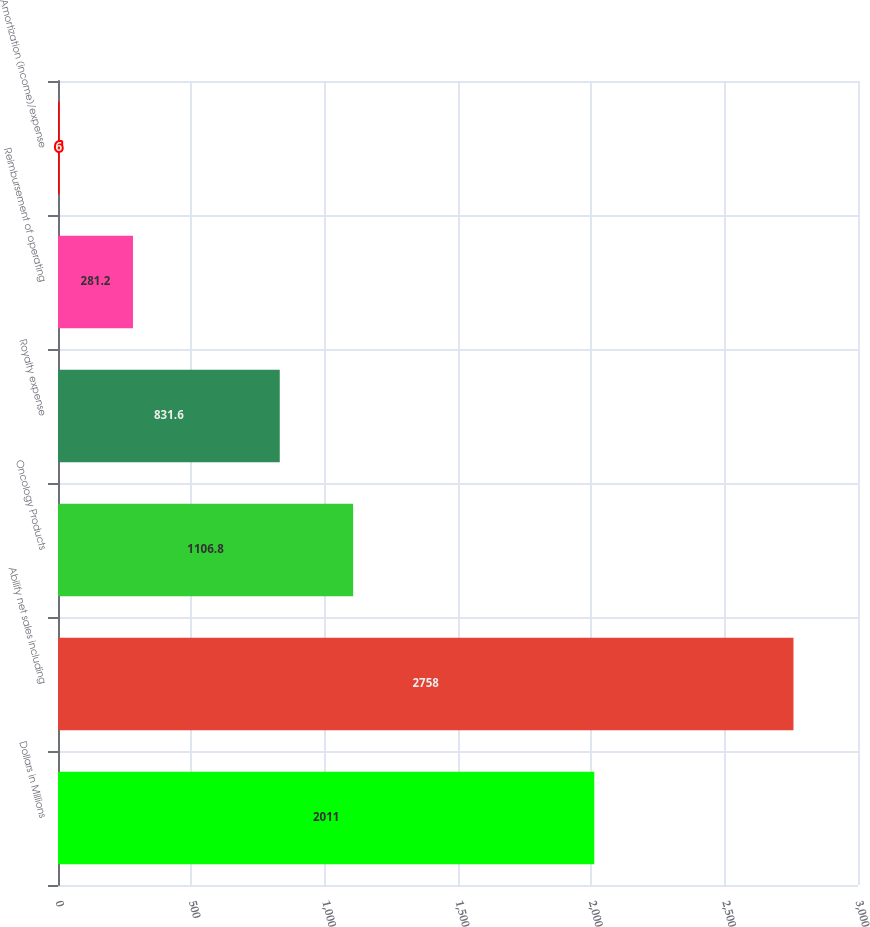Convert chart. <chart><loc_0><loc_0><loc_500><loc_500><bar_chart><fcel>Dollars in Millions<fcel>Abilify net sales including<fcel>Oncology Products<fcel>Royalty expense<fcel>Reimbursement of operating<fcel>Amortization (income)/expense<nl><fcel>2011<fcel>2758<fcel>1106.8<fcel>831.6<fcel>281.2<fcel>6<nl></chart> 